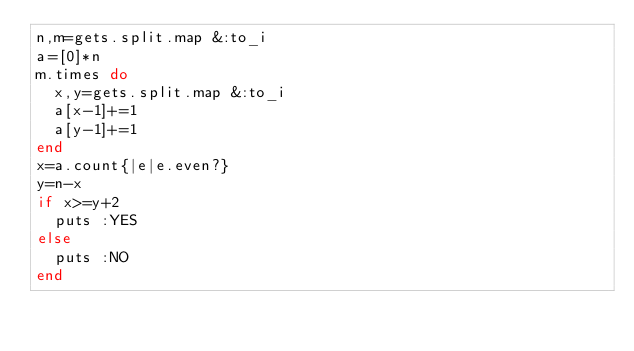Convert code to text. <code><loc_0><loc_0><loc_500><loc_500><_Ruby_>n,m=gets.split.map &:to_i
a=[0]*n
m.times do
  x,y=gets.split.map &:to_i
  a[x-1]+=1
  a[y-1]+=1
end
x=a.count{|e|e.even?}
y=n-x
if x>=y+2
  puts :YES
else
  puts :NO
end</code> 